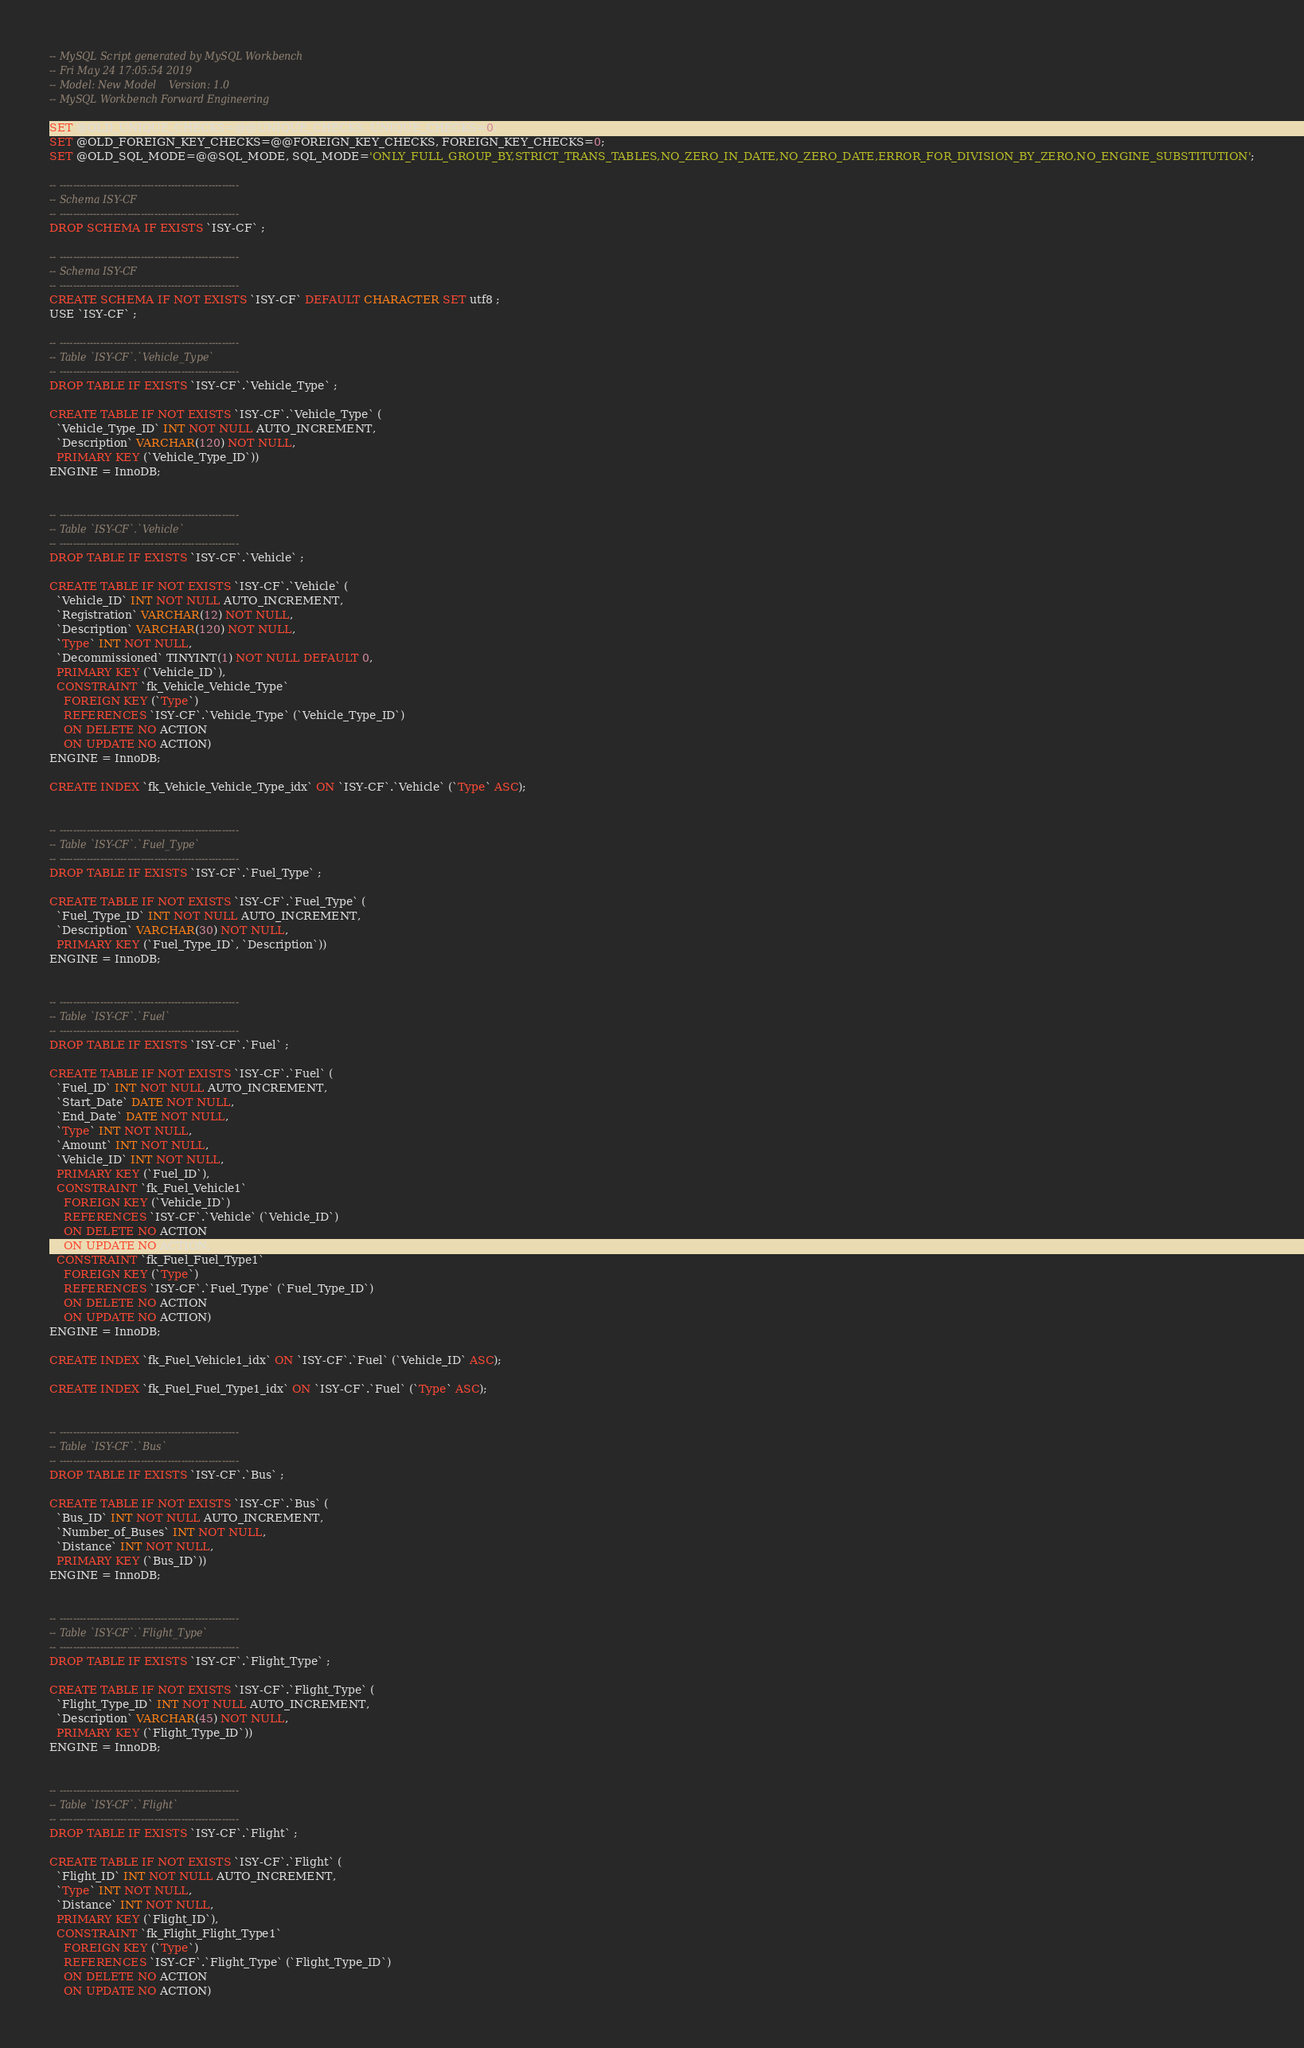Convert code to text. <code><loc_0><loc_0><loc_500><loc_500><_SQL_>-- MySQL Script generated by MySQL Workbench
-- Fri May 24 17:05:54 2019
-- Model: New Model    Version: 1.0
-- MySQL Workbench Forward Engineering

SET @OLD_UNIQUE_CHECKS=@@UNIQUE_CHECKS, UNIQUE_CHECKS=0;
SET @OLD_FOREIGN_KEY_CHECKS=@@FOREIGN_KEY_CHECKS, FOREIGN_KEY_CHECKS=0;
SET @OLD_SQL_MODE=@@SQL_MODE, SQL_MODE='ONLY_FULL_GROUP_BY,STRICT_TRANS_TABLES,NO_ZERO_IN_DATE,NO_ZERO_DATE,ERROR_FOR_DIVISION_BY_ZERO,NO_ENGINE_SUBSTITUTION';

-- -----------------------------------------------------
-- Schema ISY-CF
-- -----------------------------------------------------
DROP SCHEMA IF EXISTS `ISY-CF` ;

-- -----------------------------------------------------
-- Schema ISY-CF
-- -----------------------------------------------------
CREATE SCHEMA IF NOT EXISTS `ISY-CF` DEFAULT CHARACTER SET utf8 ;
USE `ISY-CF` ;

-- -----------------------------------------------------
-- Table `ISY-CF`.`Vehicle_Type`
-- -----------------------------------------------------
DROP TABLE IF EXISTS `ISY-CF`.`Vehicle_Type` ;

CREATE TABLE IF NOT EXISTS `ISY-CF`.`Vehicle_Type` (
  `Vehicle_Type_ID` INT NOT NULL AUTO_INCREMENT,
  `Description` VARCHAR(120) NOT NULL,
  PRIMARY KEY (`Vehicle_Type_ID`))
ENGINE = InnoDB;


-- -----------------------------------------------------
-- Table `ISY-CF`.`Vehicle`
-- -----------------------------------------------------
DROP TABLE IF EXISTS `ISY-CF`.`Vehicle` ;

CREATE TABLE IF NOT EXISTS `ISY-CF`.`Vehicle` (
  `Vehicle_ID` INT NOT NULL AUTO_INCREMENT,
  `Registration` VARCHAR(12) NOT NULL,
  `Description` VARCHAR(120) NOT NULL,
  `Type` INT NOT NULL,
  `Decommissioned` TINYINT(1) NOT NULL DEFAULT 0,
  PRIMARY KEY (`Vehicle_ID`),
  CONSTRAINT `fk_Vehicle_Vehicle_Type`
    FOREIGN KEY (`Type`)
    REFERENCES `ISY-CF`.`Vehicle_Type` (`Vehicle_Type_ID`)
    ON DELETE NO ACTION
    ON UPDATE NO ACTION)
ENGINE = InnoDB;

CREATE INDEX `fk_Vehicle_Vehicle_Type_idx` ON `ISY-CF`.`Vehicle` (`Type` ASC);


-- -----------------------------------------------------
-- Table `ISY-CF`.`Fuel_Type`
-- -----------------------------------------------------
DROP TABLE IF EXISTS `ISY-CF`.`Fuel_Type` ;

CREATE TABLE IF NOT EXISTS `ISY-CF`.`Fuel_Type` (
  `Fuel_Type_ID` INT NOT NULL AUTO_INCREMENT,
  `Description` VARCHAR(30) NOT NULL,
  PRIMARY KEY (`Fuel_Type_ID`, `Description`))
ENGINE = InnoDB;


-- -----------------------------------------------------
-- Table `ISY-CF`.`Fuel`
-- -----------------------------------------------------
DROP TABLE IF EXISTS `ISY-CF`.`Fuel` ;

CREATE TABLE IF NOT EXISTS `ISY-CF`.`Fuel` (
  `Fuel_ID` INT NOT NULL AUTO_INCREMENT,
  `Start_Date` DATE NOT NULL,
  `End_Date` DATE NOT NULL,
  `Type` INT NOT NULL,
  `Amount` INT NOT NULL,
  `Vehicle_ID` INT NOT NULL,
  PRIMARY KEY (`Fuel_ID`),
  CONSTRAINT `fk_Fuel_Vehicle1`
    FOREIGN KEY (`Vehicle_ID`)
    REFERENCES `ISY-CF`.`Vehicle` (`Vehicle_ID`)
    ON DELETE NO ACTION
    ON UPDATE NO ACTION,
  CONSTRAINT `fk_Fuel_Fuel_Type1`
    FOREIGN KEY (`Type`)
    REFERENCES `ISY-CF`.`Fuel_Type` (`Fuel_Type_ID`)
    ON DELETE NO ACTION
    ON UPDATE NO ACTION)
ENGINE = InnoDB;

CREATE INDEX `fk_Fuel_Vehicle1_idx` ON `ISY-CF`.`Fuel` (`Vehicle_ID` ASC);

CREATE INDEX `fk_Fuel_Fuel_Type1_idx` ON `ISY-CF`.`Fuel` (`Type` ASC);


-- -----------------------------------------------------
-- Table `ISY-CF`.`Bus`
-- -----------------------------------------------------
DROP TABLE IF EXISTS `ISY-CF`.`Bus` ;

CREATE TABLE IF NOT EXISTS `ISY-CF`.`Bus` (
  `Bus_ID` INT NOT NULL AUTO_INCREMENT,
  `Number_of_Buses` INT NOT NULL,
  `Distance` INT NOT NULL,
  PRIMARY KEY (`Bus_ID`))
ENGINE = InnoDB;


-- -----------------------------------------------------
-- Table `ISY-CF`.`Flight_Type`
-- -----------------------------------------------------
DROP TABLE IF EXISTS `ISY-CF`.`Flight_Type` ;

CREATE TABLE IF NOT EXISTS `ISY-CF`.`Flight_Type` (
  `Flight_Type_ID` INT NOT NULL AUTO_INCREMENT,
  `Description` VARCHAR(45) NOT NULL,
  PRIMARY KEY (`Flight_Type_ID`))
ENGINE = InnoDB;


-- -----------------------------------------------------
-- Table `ISY-CF`.`Flight`
-- -----------------------------------------------------
DROP TABLE IF EXISTS `ISY-CF`.`Flight` ;

CREATE TABLE IF NOT EXISTS `ISY-CF`.`Flight` (
  `Flight_ID` INT NOT NULL AUTO_INCREMENT,
  `Type` INT NOT NULL,
  `Distance` INT NOT NULL,
  PRIMARY KEY (`Flight_ID`),
  CONSTRAINT `fk_Flight_Flight_Type1`
    FOREIGN KEY (`Type`)
    REFERENCES `ISY-CF`.`Flight_Type` (`Flight_Type_ID`)
    ON DELETE NO ACTION
    ON UPDATE NO ACTION)</code> 